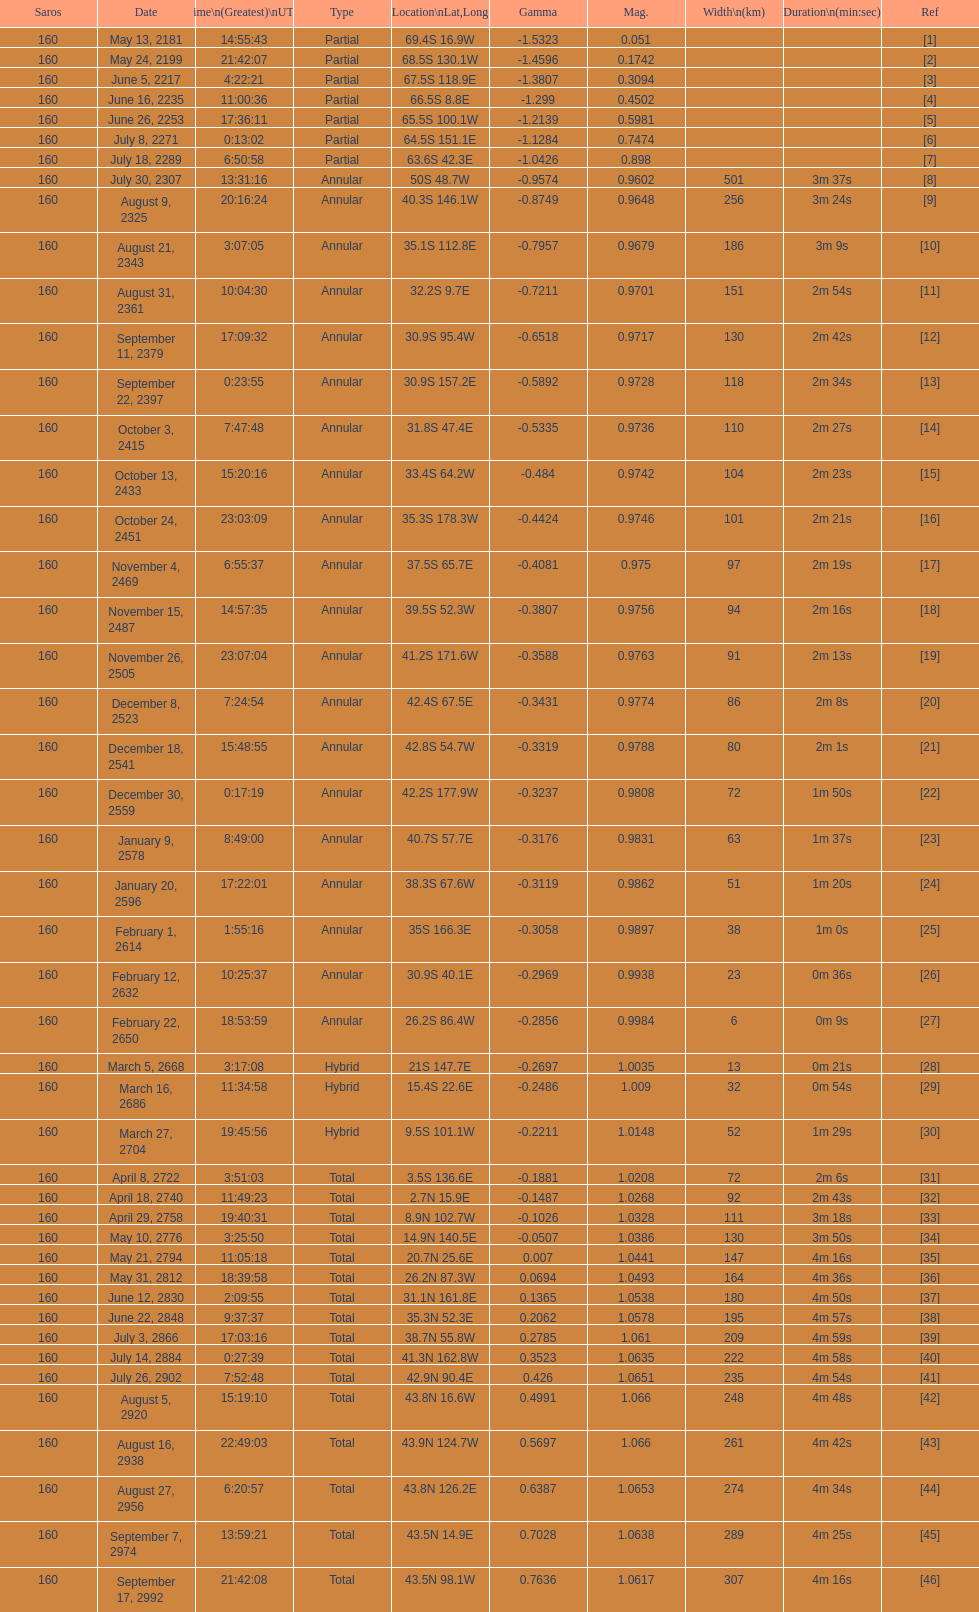Provide a member number located at a latitude exceeding 60 degrees in the southern hemisphere. 1. 